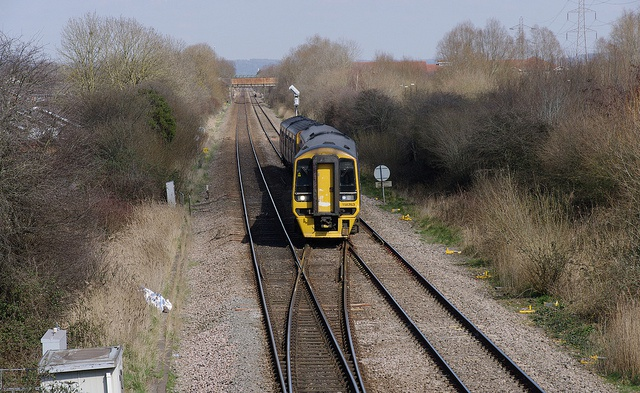Describe the objects in this image and their specific colors. I can see a train in darkgray, black, gray, and gold tones in this image. 